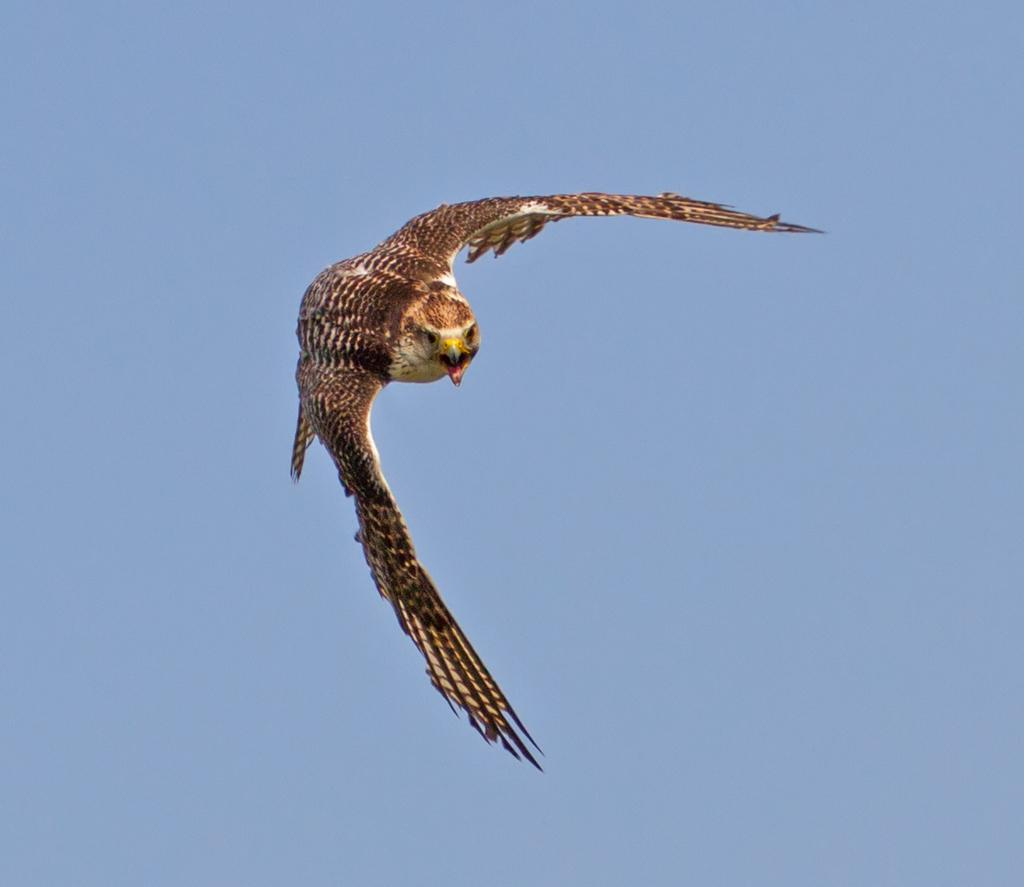What is present in the image? There is a bird in the image. What is the bird doing in the image? The bird is flying in the image. Where is the bird located in the image? The bird is in the sky in the image. What type of silk is being used to create the bird's wings in the image? There is no silk present in the image, and the bird's wings are not made of silk. 